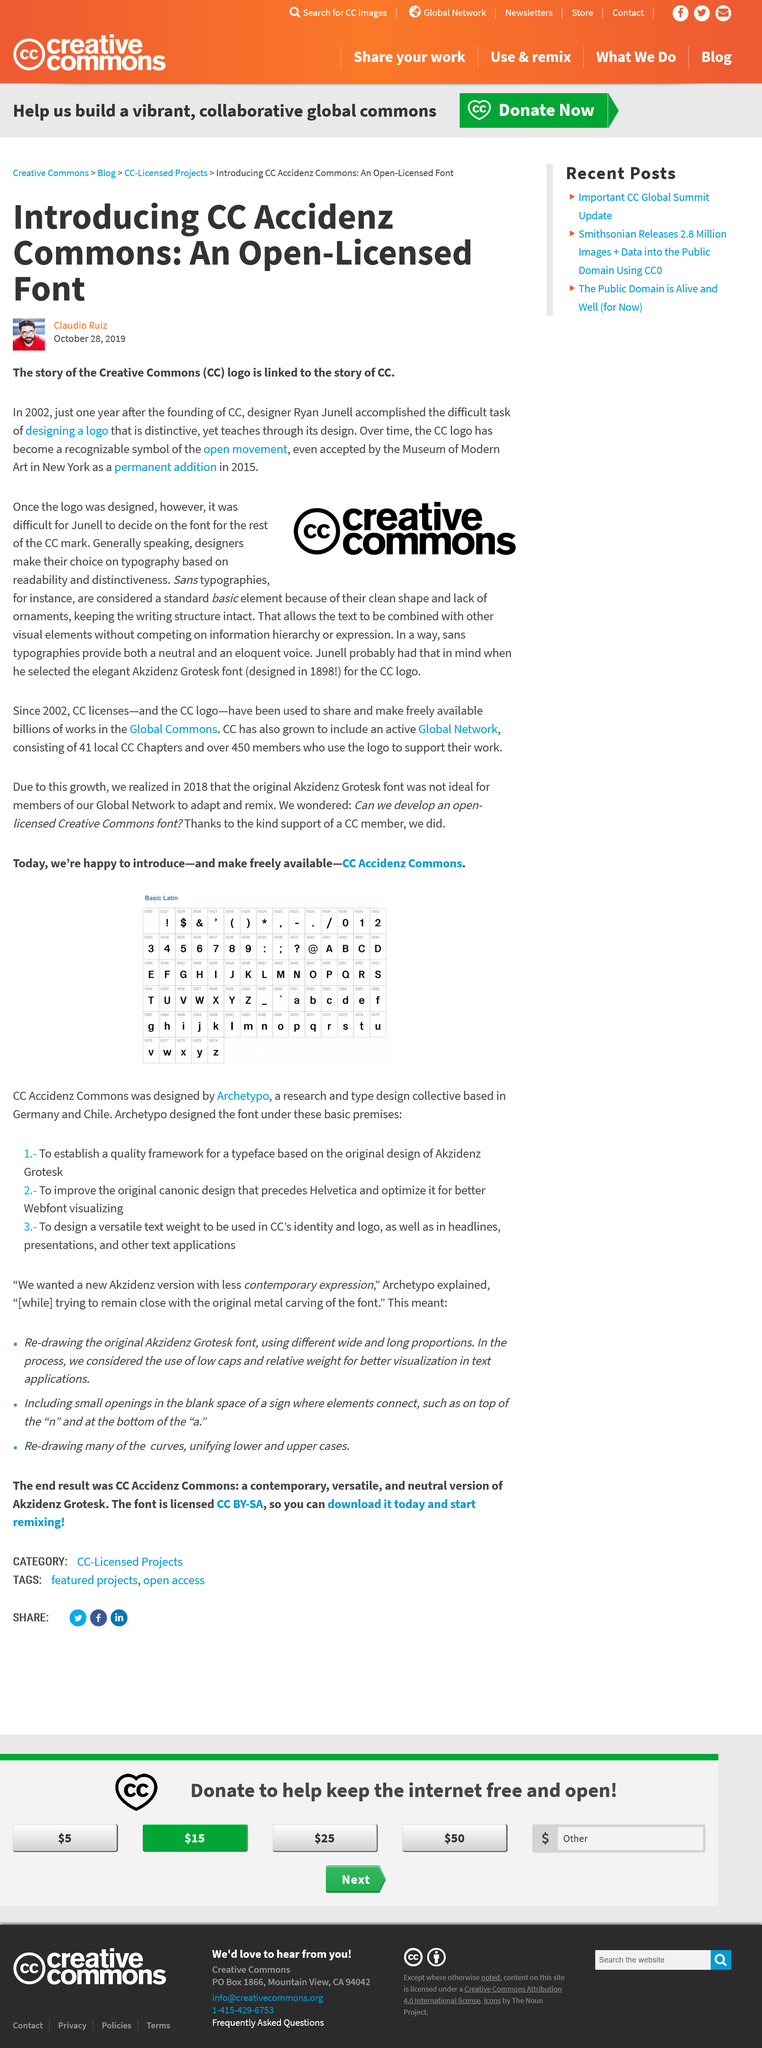Draw attention to some important aspects in this diagram. The man in the photo is wearing a red top. The creation of a unique logo took approximately one year. The article introduces CC Accidenz, a commons dedicated to promoting creative expression and collaboration through the use of AI technologies. 